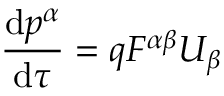<formula> <loc_0><loc_0><loc_500><loc_500>{ \frac { d p ^ { \alpha } } { d \tau } } = q F ^ { \alpha \beta } U _ { \beta }</formula> 